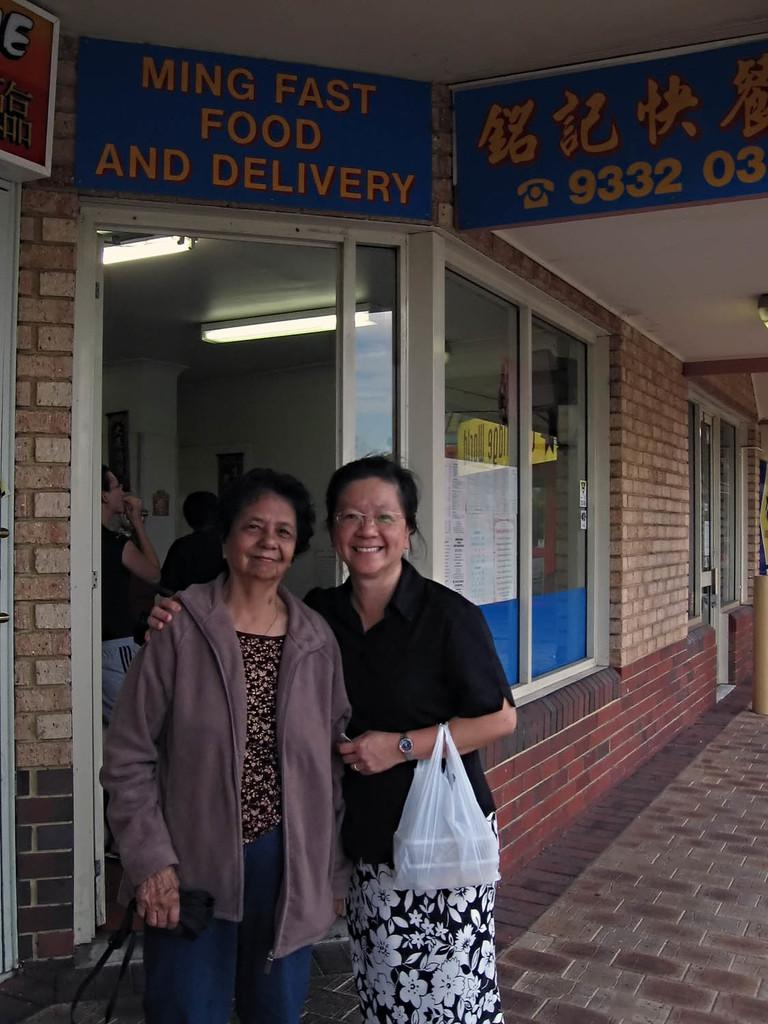What can be seen in the image involving women? There are women standing in the image, and they are holding covers. What is the setting of the image? There is a building in the image. Can you describe the building's windows? The windows have boards on them. How many knots are tied on the secretary's hair in the image? There is no secretary or knots tied on anyone's hair in the image. What type of egg is visible in the image? There are no eggs present in the image. 